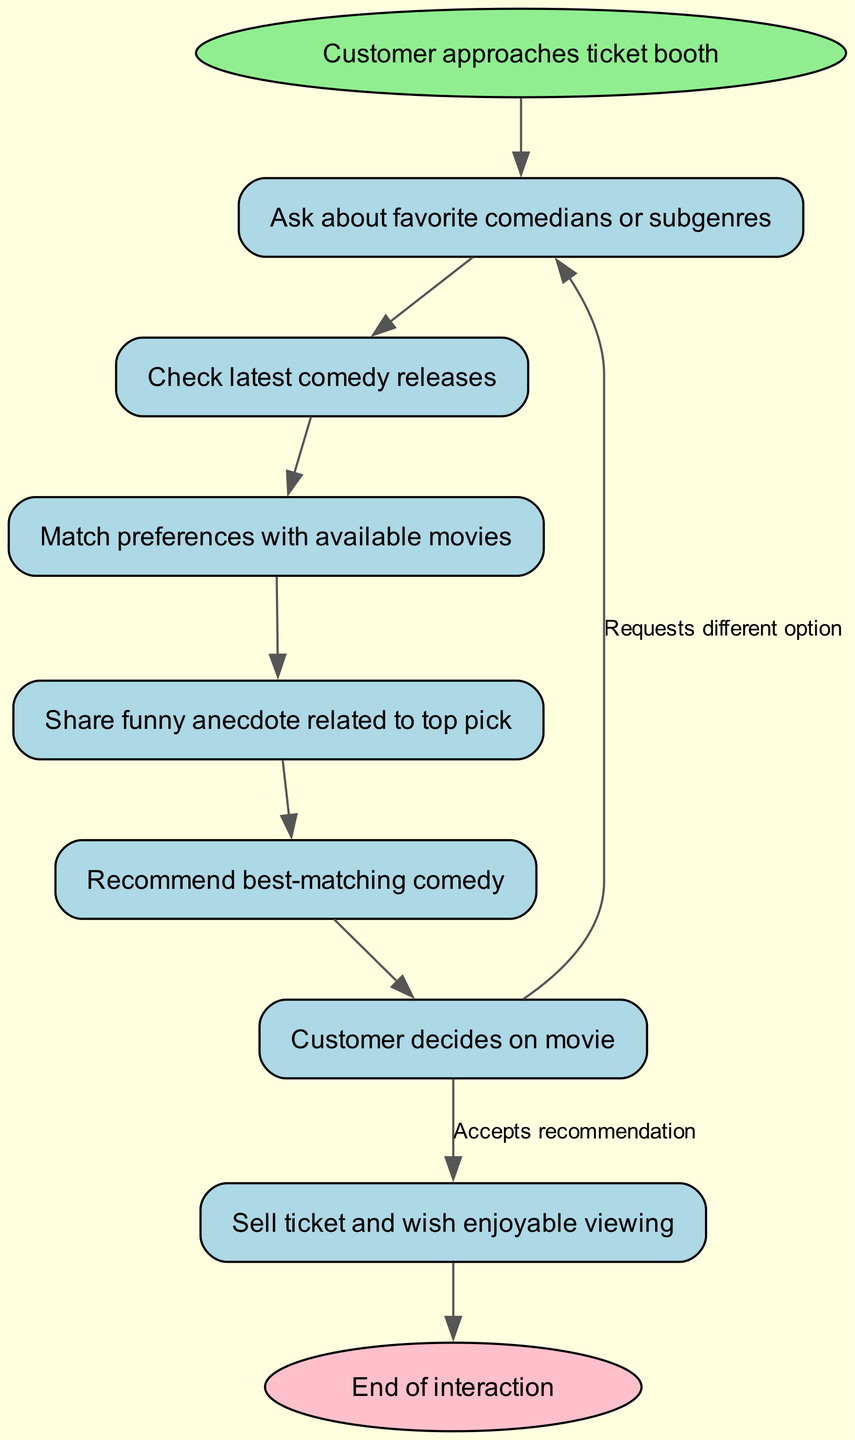What is the first action in the workflow? The first action in the workflow is indicated by the "start" node, which states "Customer approaches ticket booth." This is the starting point of the entire process before further steps take place.
Answer: Customer approaches ticket booth How many nodes are present in the diagram? To find the total number of nodes, we can count the distinct nodes listed. There are nine nodes in total, each representing a step in the workflow.
Answer: 9 What does the "customer_decision" node lead to if the recommendation is accepted? According to the diagram, if the recommendation is accepted, the "customer_decision" node leads directly to the "sell_ticket" node, which indicates the process of selling a ticket.
Answer: sell_ticket What happens after sharing an anecdote? After the "share_anecdote" node, the next step indicated is the "recommend_movie" node. This shows that sharing an anecdote is followed by recommending the best-matching comedy movie.
Answer: recommend_movie How many edges point out from the "customer_decision" node? The "customer_decision" node has two edges pointing out from it: one leading to "sell_ticket" if the recommendation is accepted and the other looping back to "ask_preferences" if the customer requests a different option.
Answer: 2 What type of node is the "start" node categorized as? The "start" node is categorized as an ellipse in the diagram, which is a specific shape used to indicate the beginning of the workflow process, in contrast to the rectangular nodes that represent other steps.
Answer: ellipse What is the last action in the workflow? The last action in the workflow is represented by the "end" node, which signifies the conclusion of the interaction process with the customer after the ticket has been sold.
Answer: End of interaction What is the purpose of checking new releases in the workflow? Checking new releases serves as a decision-making step where the vendor assesses the currently available comedy films to provide the customer with the most up-to-date options based on their preferences.
Answer: To find the latest comedy releases 